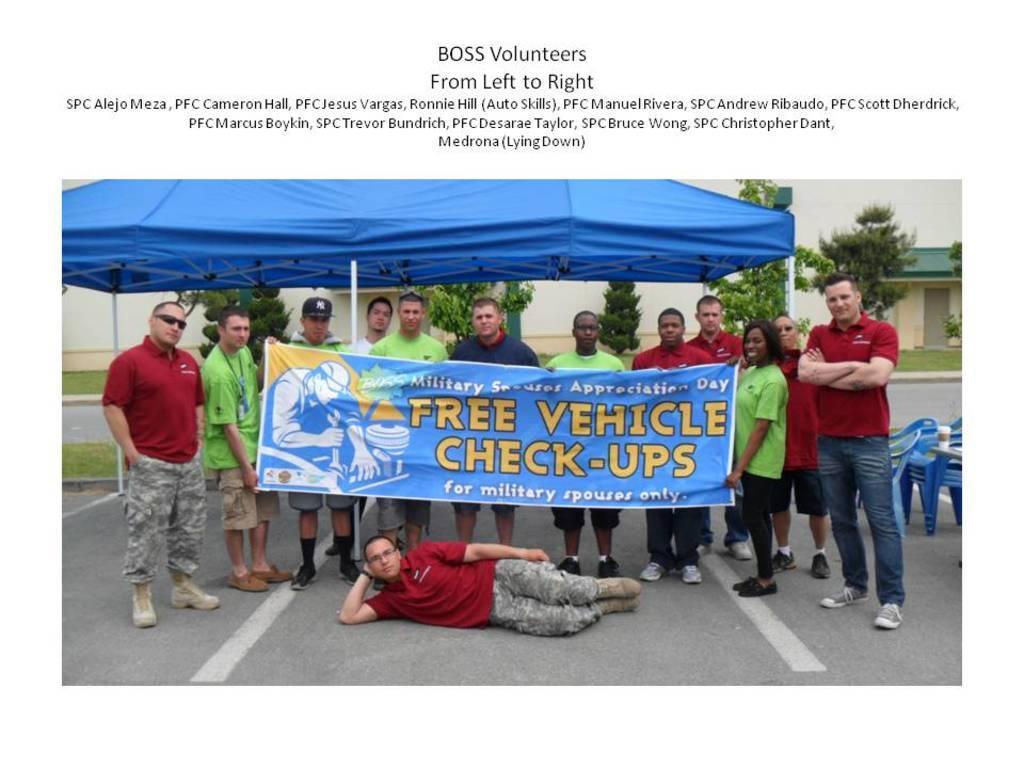Can you describe this image briefly? In this image there are a few people standing by holding a banner, in front of the banner there is a person lay on the road, behind them there is a tent, behind the tent there are trees and buildings, beside them there are empty chairs with a coffee mug on it, at the top of the image there is some text written on it. 